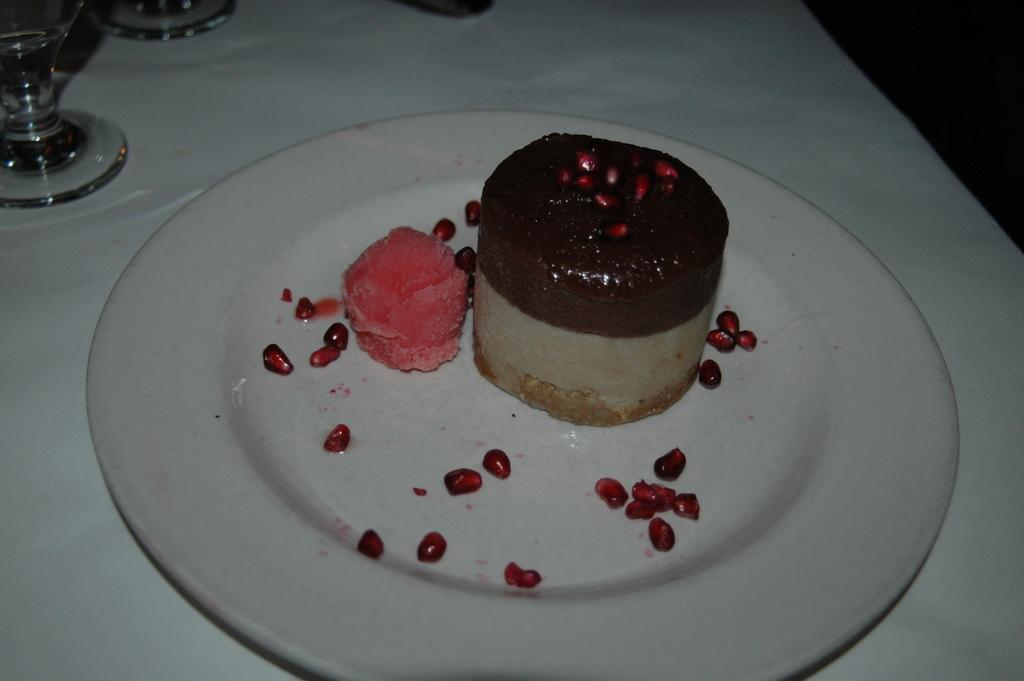What piece of furniture is present in the image? There is a table in the image. What is placed on the table? There is a plate, pomegranate seeds, an ice cream scoop, a cake, and glasses on the table. What type of food can be seen on the plate? There are pomegranate seeds on the plate. What utensil is present on the table? There is an ice cream scoop on the table. What type of dessert is visible on the table? There is a cake on the table. What type of dishware is present on the table? There are glasses on the table. Is the woman carrying a parcel in the image? There is no woman or parcel present in the image. What type of creature is sitting on the cake in the image? There is no creature sitting on the cake in the image. 